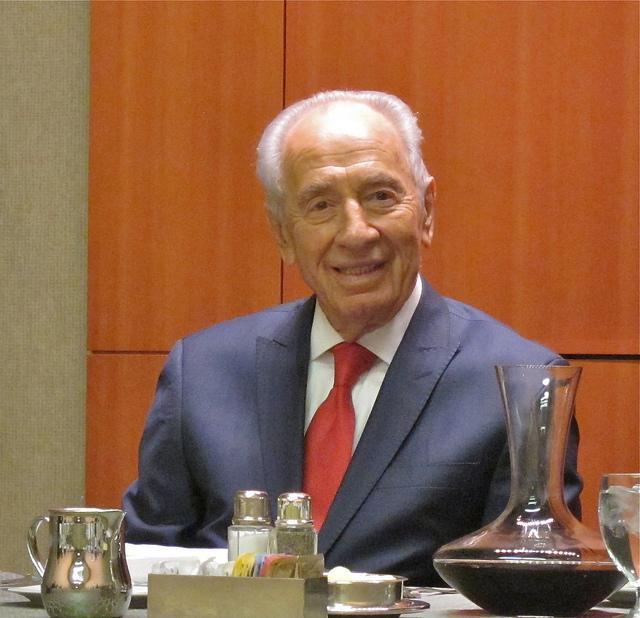How many bottles are visible?
Give a very brief answer. 2. 